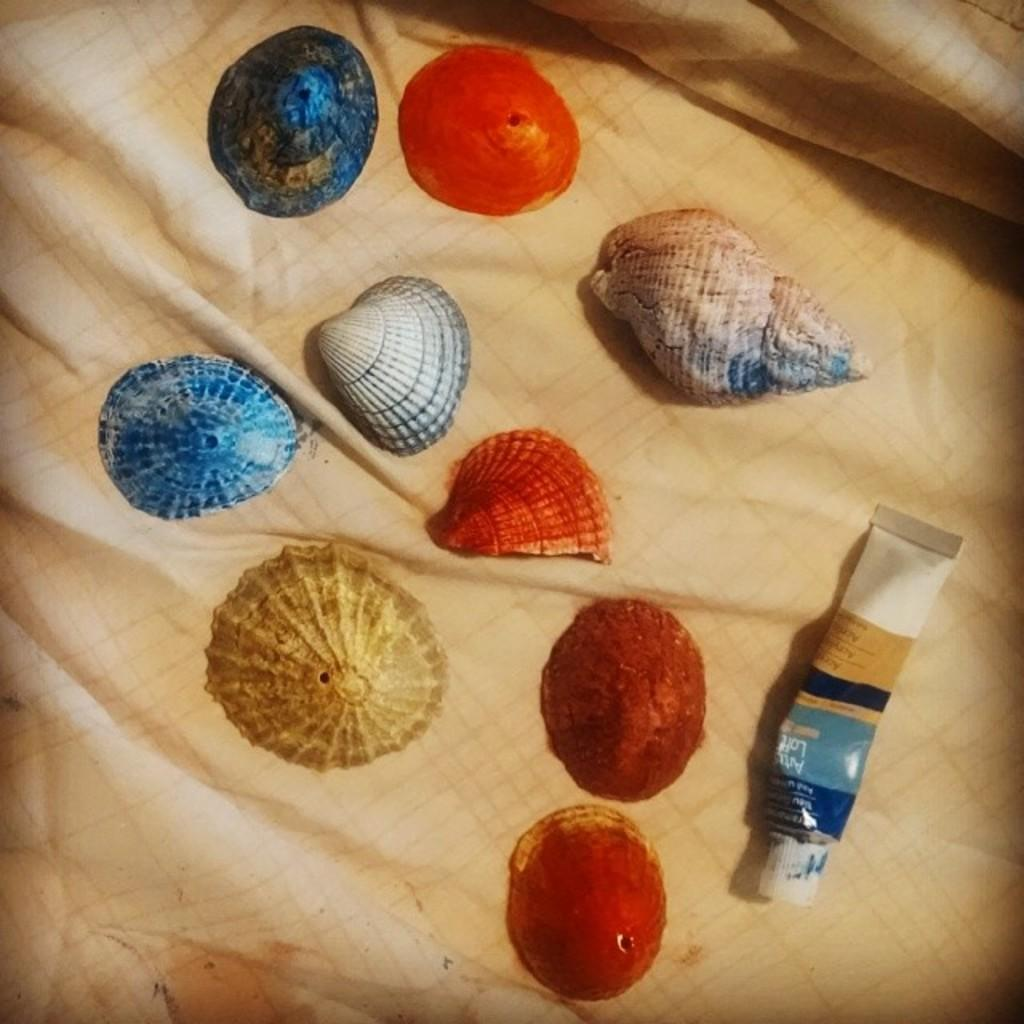What type of objects can be seen in the image? There are shells and a tube in the image. What is the tube used for? The purpose of the tube is not specified in the image. What is the shells and tube placed on? The shells and tube are placed on a cloth. Is there a flame visible in the image? No, there is no flame present in the image. Is there an advertisement displayed in the image? No, there is no advertisement present in the image. 